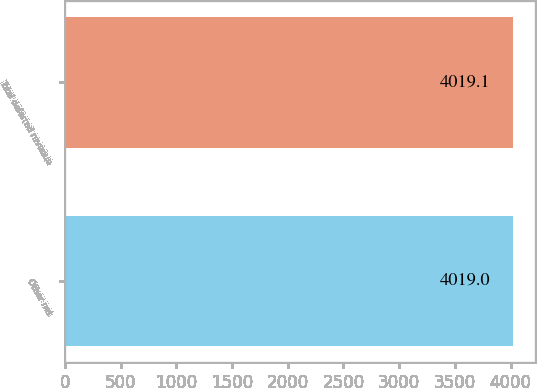Convert chart to OTSL. <chart><loc_0><loc_0><loc_500><loc_500><bar_chart><fcel>Other net<fcel>Total deferred revenue<nl><fcel>4019<fcel>4019.1<nl></chart> 